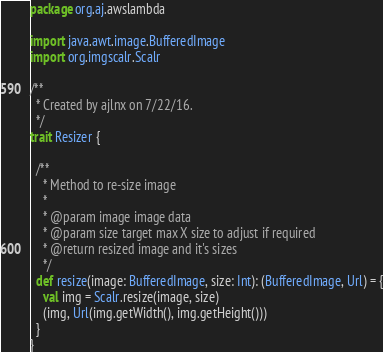Convert code to text. <code><loc_0><loc_0><loc_500><loc_500><_Scala_>package org.aj.awslambda

import java.awt.image.BufferedImage
import org.imgscalr.Scalr

/**
  * Created by ajlnx on 7/22/16.
  */
trait Resizer {

  /**
    * Method to re-size image
    *
    * @param image image data
    * @param size target max X size to adjust if required
    * @return resized image and it's sizes
    */
  def resize(image: BufferedImage, size: Int): (BufferedImage, Url) = {
    val img = Scalr.resize(image, size)
    (img, Url(img.getWidth(), img.getHeight()))
  }
}</code> 